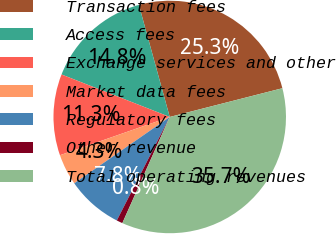Convert chart. <chart><loc_0><loc_0><loc_500><loc_500><pie_chart><fcel>Transaction fees<fcel>Access fees<fcel>Exchange services and other<fcel>Market data fees<fcel>Regulatory fees<fcel>Other revenue<fcel>Total operating revenues<nl><fcel>25.3%<fcel>14.77%<fcel>11.29%<fcel>4.33%<fcel>7.81%<fcel>0.84%<fcel>35.66%<nl></chart> 